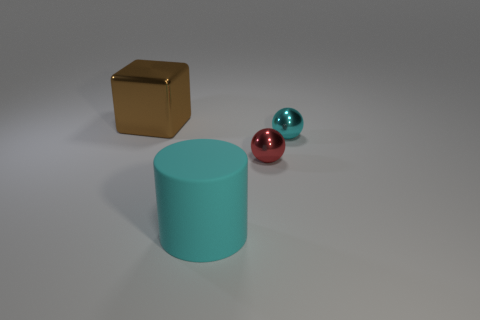Add 4 small red metal things. How many objects exist? 8 Subtract all cubes. How many objects are left? 3 Add 3 tiny shiny spheres. How many tiny shiny spheres are left? 5 Add 3 small brown cylinders. How many small brown cylinders exist? 3 Subtract 0 yellow cubes. How many objects are left? 4 Subtract all large objects. Subtract all big rubber cylinders. How many objects are left? 1 